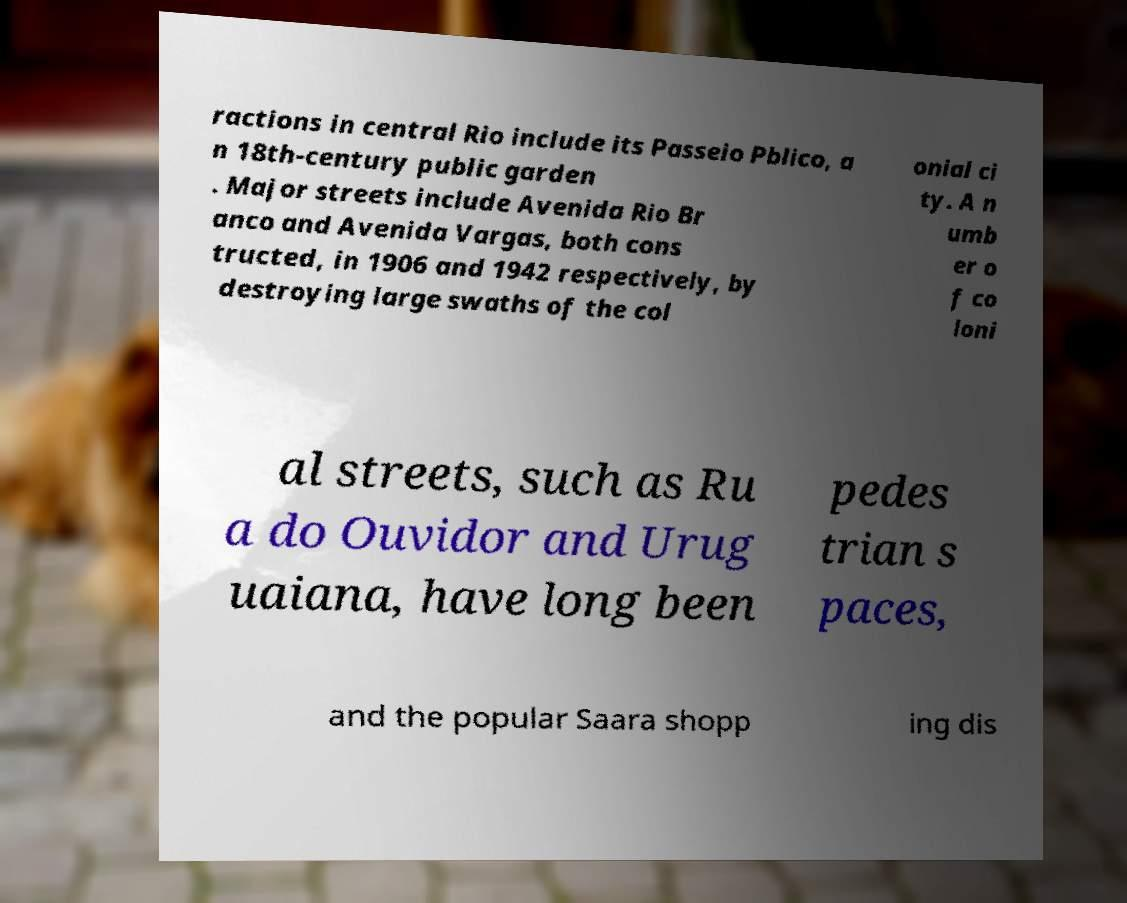There's text embedded in this image that I need extracted. Can you transcribe it verbatim? ractions in central Rio include its Passeio Pblico, a n 18th-century public garden . Major streets include Avenida Rio Br anco and Avenida Vargas, both cons tructed, in 1906 and 1942 respectively, by destroying large swaths of the col onial ci ty. A n umb er o f co loni al streets, such as Ru a do Ouvidor and Urug uaiana, have long been pedes trian s paces, and the popular Saara shopp ing dis 